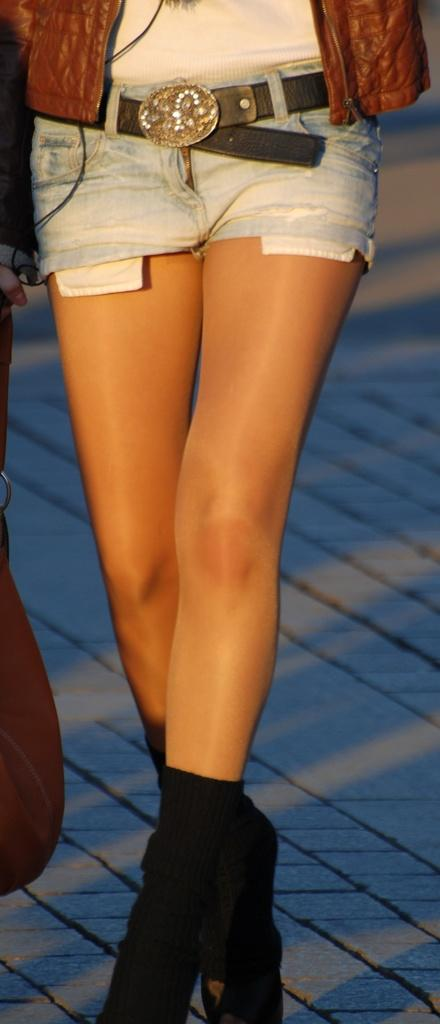What is the main subject of the image? There is a person in the image. What type of clothing is the person wearing on their lower body? The person is wearing shorts. What type of footwear is the person wearing? The person is wearing black boots. What type of outerwear is the person wearing? The person is wearing a brown jacket. What color of paint is being used by the person in the image? There is no indication in the image that the person is using paint, so it cannot be determined from the picture. 